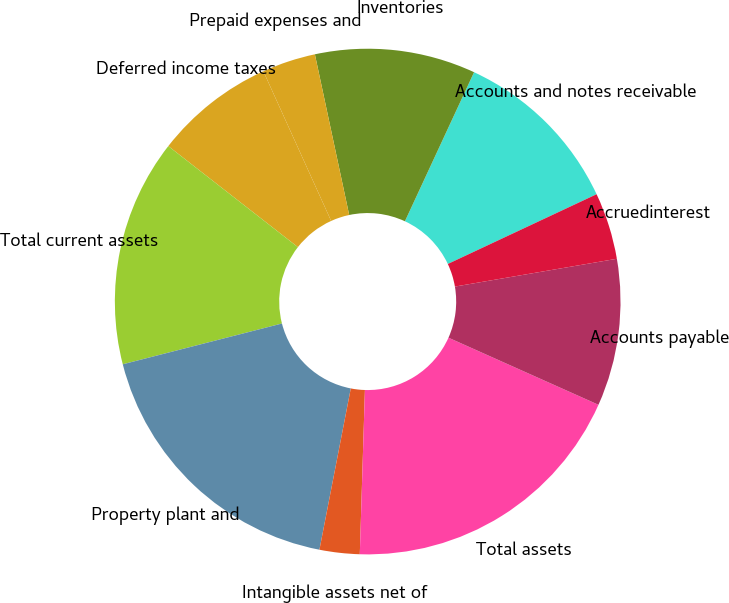<chart> <loc_0><loc_0><loc_500><loc_500><pie_chart><fcel>Accounts and notes receivable<fcel>Inventories<fcel>Prepaid expenses and<fcel>Deferred income taxes<fcel>Total current assets<fcel>Property plant and<fcel>Intangible assets net of<fcel>Total assets<fcel>Accounts payable<fcel>Accruedinterest<nl><fcel>11.11%<fcel>10.26%<fcel>3.42%<fcel>7.69%<fcel>14.53%<fcel>17.95%<fcel>2.56%<fcel>18.8%<fcel>9.4%<fcel>4.27%<nl></chart> 